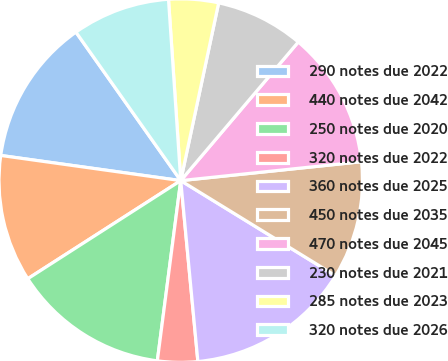Convert chart. <chart><loc_0><loc_0><loc_500><loc_500><pie_chart><fcel>290 notes due 2022<fcel>440 notes due 2042<fcel>250 notes due 2020<fcel>320 notes due 2022<fcel>360 notes due 2025<fcel>450 notes due 2035<fcel>470 notes due 2045<fcel>230 notes due 2021<fcel>285 notes due 2023<fcel>320 notes due 2026<nl><fcel>13.01%<fcel>11.29%<fcel>13.87%<fcel>3.56%<fcel>14.73%<fcel>10.43%<fcel>12.15%<fcel>7.85%<fcel>4.42%<fcel>8.71%<nl></chart> 